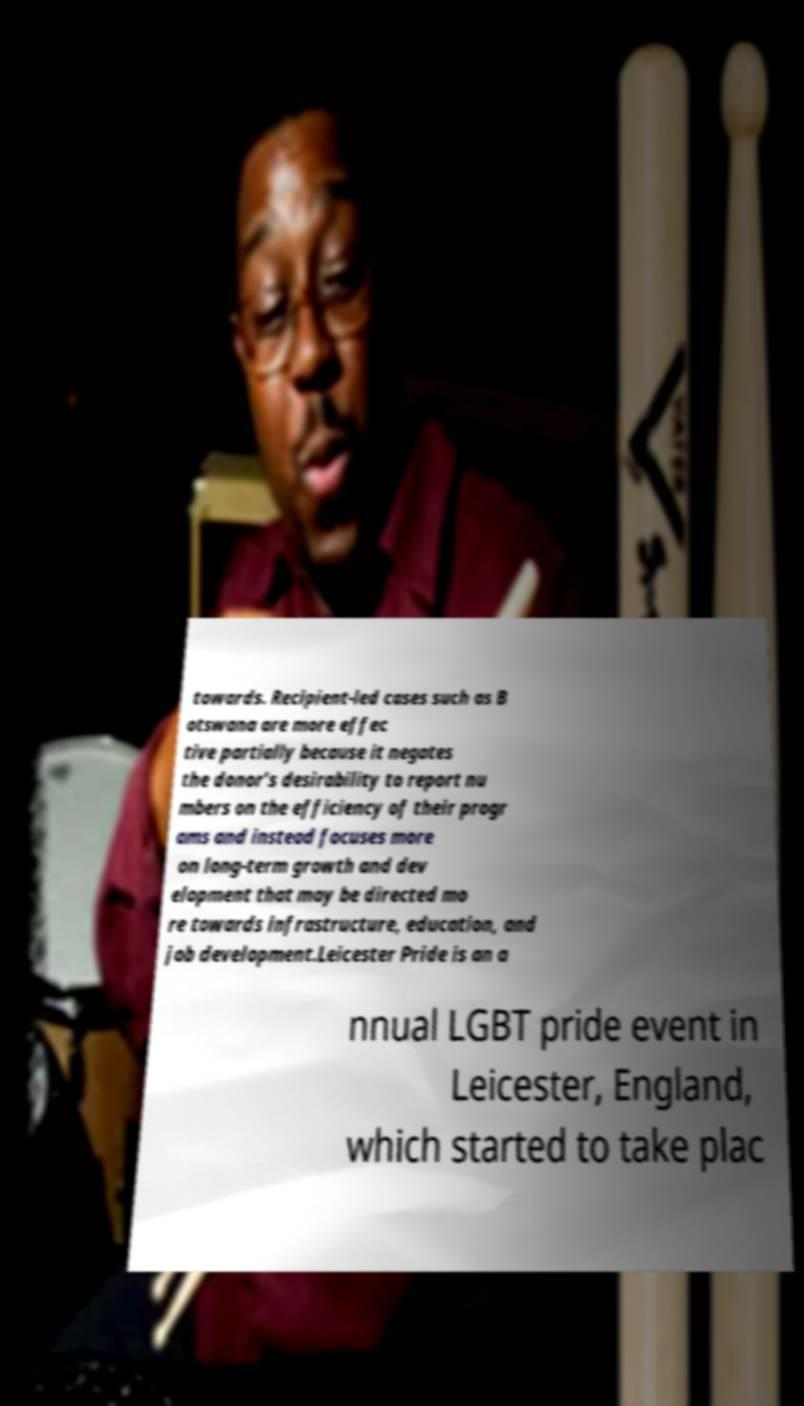There's text embedded in this image that I need extracted. Can you transcribe it verbatim? towards. Recipient-led cases such as B otswana are more effec tive partially because it negates the donor’s desirability to report nu mbers on the efficiency of their progr ams and instead focuses more on long-term growth and dev elopment that may be directed mo re towards infrastructure, education, and job development.Leicester Pride is an a nnual LGBT pride event in Leicester, England, which started to take plac 